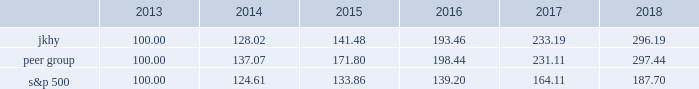14 2018 annual report performance graph the following chart presents a comparison for the five-year period ended june 30 , 2018 , of the market performance of the company 2019s common stock with the s&p 500 index and an index of peer companies selected by the company .
Historic stock price performance is not necessarily indicative of future stock price performance .
Comparison of 5 year cumulative total return among jack henry & associates , inc. , the s&p 500 index , and a peer group the following information depicts a line graph with the following values: .
This comparison assumes $ 100 was invested on june 30 , 2013 , and assumes reinvestments of dividends .
Total returns are calculated according to market capitalization of peer group members at the beginning of each period .
Peer companies selected are in the business of providing specialized computer software , hardware and related services to financial institutions and other businesses .
Companies in the peer group are aci worldwide , inc. ; bottomline technology , inc. ; broadridge financial solutions ; cardtronics , inc. ; convergys corp. ; corelogic , inc. ; euronet worldwide , inc. ; fair isaac corp. ; fidelity national information services , inc. ; fiserv , inc. ; global payments , inc. ; moneygram international , inc. ; ss&c technologies holdings , inc. ; total systems services , inc. ; tyler technologies , inc. ; verifone systems , inc. ; and wex , inc .
Dst systems , inc. , which had previously been part of the peer group , was acquired in 2018 and is no longer a public company .
As a result , dst systems , inc .
Has been removed from the peer group and stock performance graph .
The stock performance graph shall not be deemed 201cfiled 201d for purposes of section 18 of the exchange act , or incorporated by reference into any filing of the company under the securities act of 1933 , as amended , or the exchange act , except as shall be expressly set forth by specific reference in such filing. .
What was the percentage growth of the jkhy? 
Computations: (128.02 + 100.00)
Answer: 228.02. 